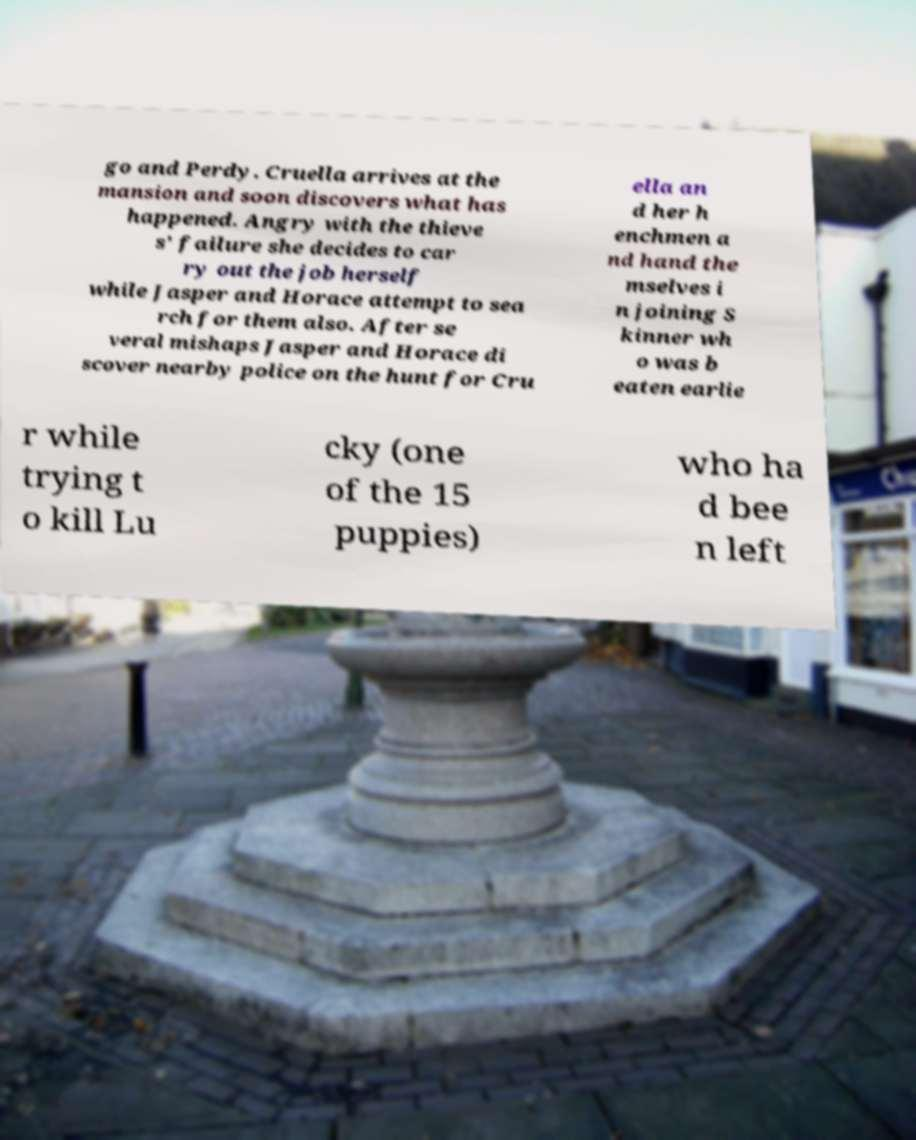There's text embedded in this image that I need extracted. Can you transcribe it verbatim? go and Perdy. Cruella arrives at the mansion and soon discovers what has happened. Angry with the thieve s' failure she decides to car ry out the job herself while Jasper and Horace attempt to sea rch for them also. After se veral mishaps Jasper and Horace di scover nearby police on the hunt for Cru ella an d her h enchmen a nd hand the mselves i n joining S kinner wh o was b eaten earlie r while trying t o kill Lu cky (one of the 15 puppies) who ha d bee n left 